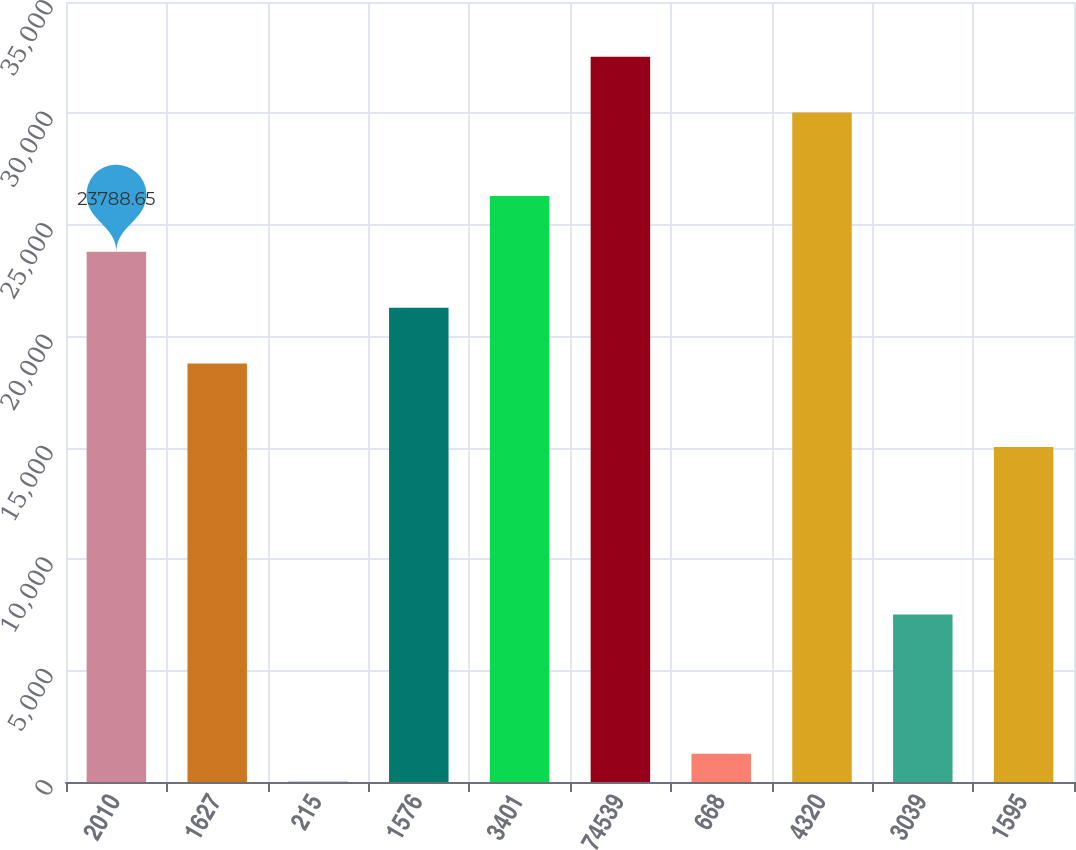Convert chart. <chart><loc_0><loc_0><loc_500><loc_500><bar_chart><fcel>2010<fcel>1627<fcel>215<fcel>1576<fcel>3401<fcel>74539<fcel>668<fcel>4320<fcel>3039<fcel>1595<nl><fcel>23788.7<fcel>18783<fcel>11.86<fcel>21285.8<fcel>26291.5<fcel>32548.5<fcel>1263.27<fcel>30045.7<fcel>7520.32<fcel>15028.8<nl></chart> 